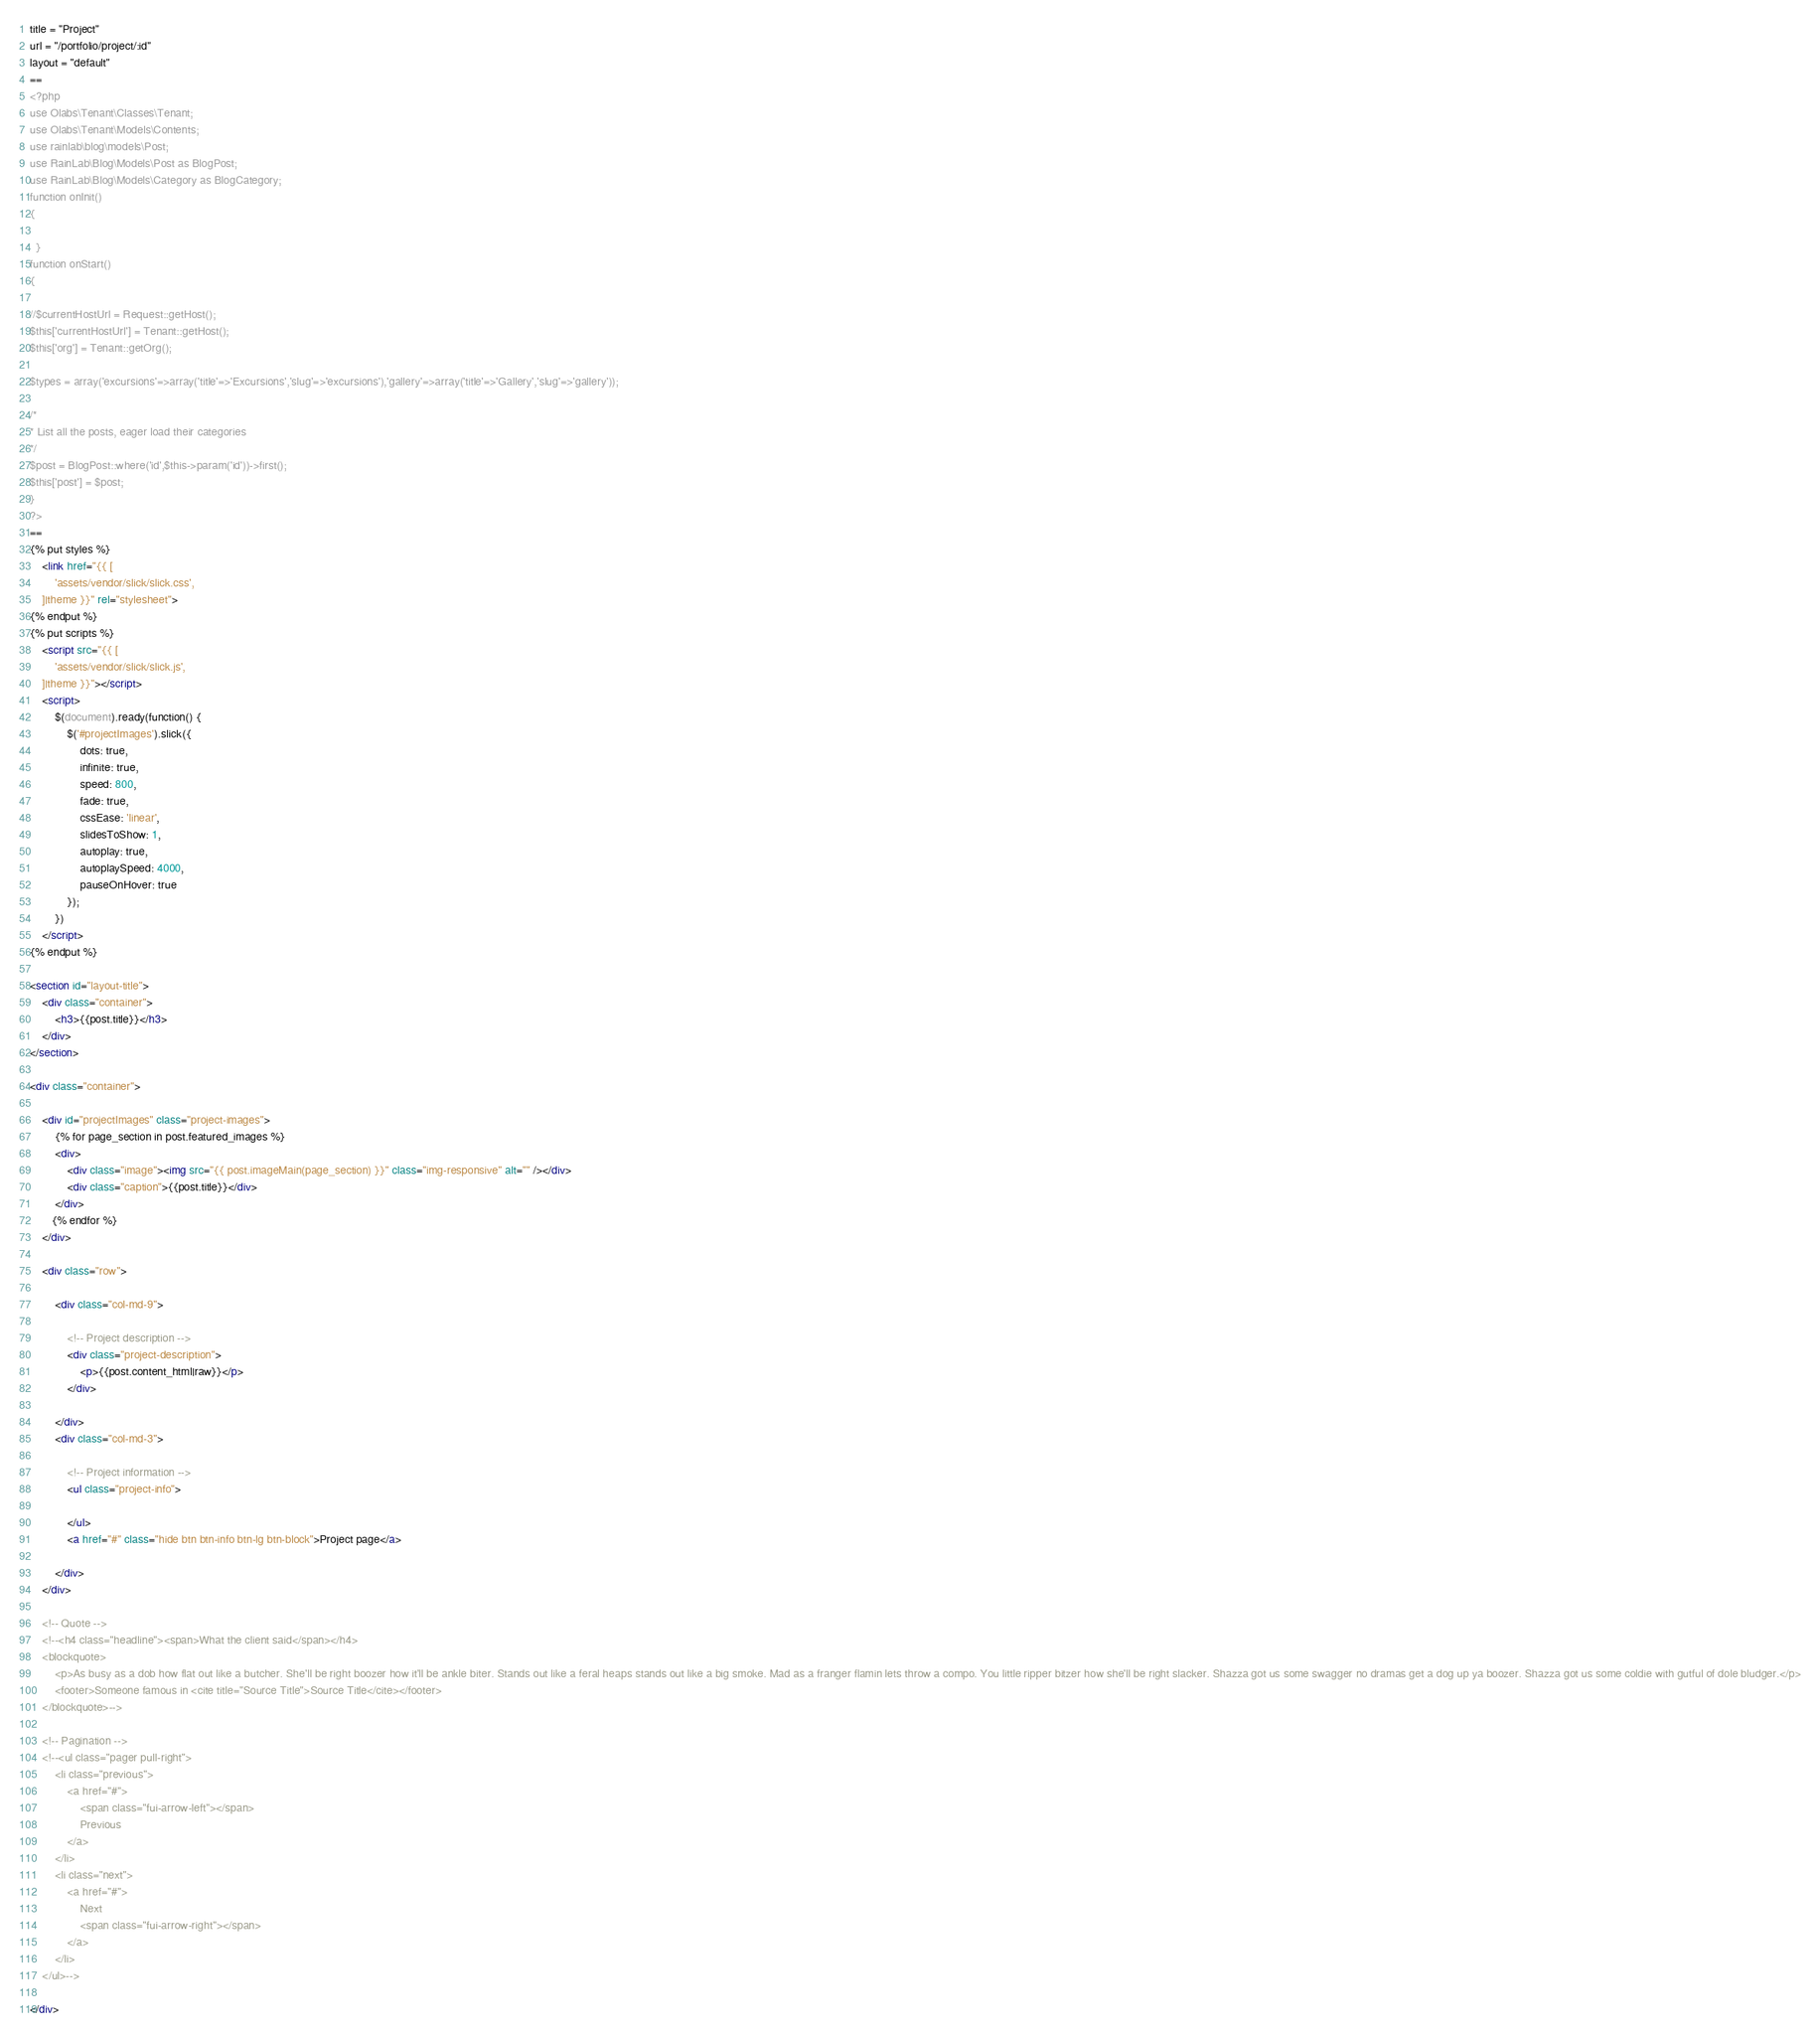<code> <loc_0><loc_0><loc_500><loc_500><_HTML_>title = "Project"
url = "/portfolio/project/:id"
layout = "default"
==
<?php
use Olabs\Tenant\Classes\Tenant;
use Olabs\Tenant\Models\Contents;
use rainlab\blog\models\Post;
use RainLab\Blog\Models\Post as BlogPost;
use RainLab\Blog\Models\Category as BlogCategory;
function onInit()
{

  }
function onStart()
{

//$currentHostUrl = Request::getHost();
$this['currentHostUrl'] = Tenant::getHost();
$this['org'] = Tenant::getOrg();

$types = array('excursions'=>array('title'=>'Excursions','slug'=>'excursions'),'gallery'=>array('title'=>'Gallery','slug'=>'gallery'));

/*
* List all the posts, eager load their categories
*/
$post = BlogPost::where('id',$this->param('id'))->first();
$this['post'] = $post;
}
?>
==
{% put styles %}
    <link href="{{ [
        'assets/vendor/slick/slick.css',
    ]|theme }}" rel="stylesheet">
{% endput %}
{% put scripts %}
    <script src="{{ [
        'assets/vendor/slick/slick.js',
    ]|theme }}"></script>
    <script>
        $(document).ready(function() {
            $('#projectImages').slick({
                dots: true,
                infinite: true,
                speed: 800,
                fade: true,
                cssEase: 'linear',
                slidesToShow: 1,
                autoplay: true,
                autoplaySpeed: 4000,
                pauseOnHover: true
            });
        })
    </script>
{% endput %}

<section id="layout-title">
    <div class="container">
        <h3>{{post.title}}</h3>
    </div>
</section>

<div class="container">

    <div id="projectImages" class="project-images">
        {% for page_section in post.featured_images %}
        <div>
            <div class="image"><img src="{{ post.imageMain(page_section) }}" class="img-responsive" alt="" /></div>
            <div class="caption">{{post.title}}</div>
        </div>
       {% endfor %}
    </div>

    <div class="row">

        <div class="col-md-9">

            <!-- Project description -->
            <div class="project-description">
                <p>{{post.content_html|raw}}</p>
            </div>

        </div>
        <div class="col-md-3">

            <!-- Project information -->
            <ul class="project-info">

            </ul>
            <a href="#" class="hide btn btn-info btn-lg btn-block">Project page</a>

        </div>
    </div>

    <!-- Quote -->
    <!--<h4 class="headline"><span>What the client said</span></h4>
    <blockquote>
        <p>As busy as a dob how flat out like a butcher. She'll be right boozer how it'll be ankle biter. Stands out like a feral heaps stands out like a big smoke. Mad as a franger flamin lets throw a compo. You little ripper bitzer how she'll be right slacker. Shazza got us some swagger no dramas get a dog up ya boozer. Shazza got us some coldie with gutful of dole bludger.</p>
        <footer>Someone famous in <cite title="Source Title">Source Title</cite></footer>
    </blockquote>-->

    <!-- Pagination -->
    <!--<ul class="pager pull-right">
        <li class="previous">
            <a href="#">
                <span class="fui-arrow-left"></span>
                Previous
            </a>
        </li>
        <li class="next">
            <a href="#">
                Next
                <span class="fui-arrow-right"></span>
            </a>
        </li>
    </ul>-->

</div></code> 